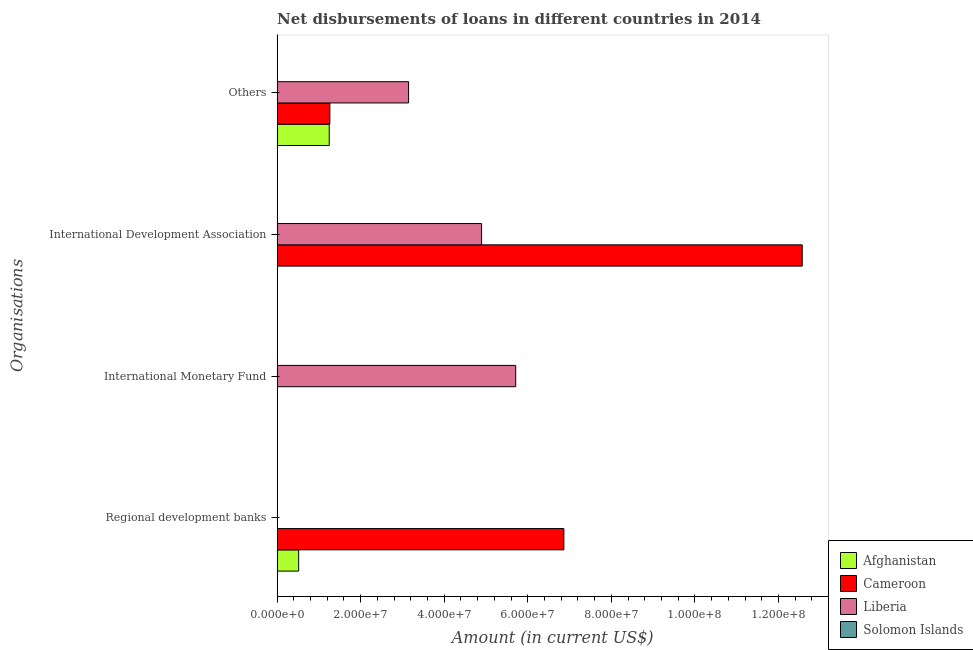How many different coloured bars are there?
Your answer should be compact. 3. Are the number of bars on each tick of the Y-axis equal?
Offer a very short reply. No. How many bars are there on the 1st tick from the top?
Make the answer very short. 3. What is the label of the 3rd group of bars from the top?
Your answer should be compact. International Monetary Fund. What is the amount of loan disimbursed by international development association in Cameroon?
Your answer should be compact. 1.26e+08. Across all countries, what is the maximum amount of loan disimbursed by international development association?
Your answer should be compact. 1.26e+08. In which country was the amount of loan disimbursed by international development association maximum?
Provide a short and direct response. Cameroon. What is the total amount of loan disimbursed by other organisations in the graph?
Offer a very short reply. 5.66e+07. What is the difference between the amount of loan disimbursed by regional development banks in Cameroon and that in Afghanistan?
Keep it short and to the point. 6.35e+07. What is the difference between the amount of loan disimbursed by international monetary fund in Cameroon and the amount of loan disimbursed by regional development banks in Afghanistan?
Provide a succinct answer. -5.16e+06. What is the average amount of loan disimbursed by other organisations per country?
Make the answer very short. 1.41e+07. What is the difference between the amount of loan disimbursed by regional development banks and amount of loan disimbursed by other organisations in Afghanistan?
Ensure brevity in your answer.  -7.32e+06. In how many countries, is the amount of loan disimbursed by international development association greater than 72000000 US$?
Offer a terse response. 1. What is the difference between the highest and the second highest amount of loan disimbursed by other organisations?
Your answer should be compact. 1.88e+07. What is the difference between the highest and the lowest amount of loan disimbursed by international development association?
Keep it short and to the point. 1.26e+08. In how many countries, is the amount of loan disimbursed by international monetary fund greater than the average amount of loan disimbursed by international monetary fund taken over all countries?
Offer a very short reply. 1. Is it the case that in every country, the sum of the amount of loan disimbursed by regional development banks and amount of loan disimbursed by international monetary fund is greater than the amount of loan disimbursed by international development association?
Offer a terse response. No. Are all the bars in the graph horizontal?
Your answer should be compact. Yes. How many countries are there in the graph?
Your response must be concise. 4. Does the graph contain any zero values?
Ensure brevity in your answer.  Yes. Where does the legend appear in the graph?
Keep it short and to the point. Bottom right. What is the title of the graph?
Provide a short and direct response. Net disbursements of loans in different countries in 2014. Does "OECD members" appear as one of the legend labels in the graph?
Make the answer very short. No. What is the label or title of the X-axis?
Provide a short and direct response. Amount (in current US$). What is the label or title of the Y-axis?
Provide a succinct answer. Organisations. What is the Amount (in current US$) of Afghanistan in Regional development banks?
Offer a terse response. 5.16e+06. What is the Amount (in current US$) of Cameroon in Regional development banks?
Your answer should be compact. 6.86e+07. What is the Amount (in current US$) in Afghanistan in International Monetary Fund?
Give a very brief answer. 0. What is the Amount (in current US$) in Cameroon in International Monetary Fund?
Offer a terse response. 0. What is the Amount (in current US$) of Liberia in International Monetary Fund?
Give a very brief answer. 5.71e+07. What is the Amount (in current US$) in Afghanistan in International Development Association?
Offer a very short reply. 0. What is the Amount (in current US$) of Cameroon in International Development Association?
Make the answer very short. 1.26e+08. What is the Amount (in current US$) of Liberia in International Development Association?
Provide a short and direct response. 4.89e+07. What is the Amount (in current US$) in Afghanistan in Others?
Your answer should be compact. 1.25e+07. What is the Amount (in current US$) in Cameroon in Others?
Offer a terse response. 1.26e+07. What is the Amount (in current US$) in Liberia in Others?
Ensure brevity in your answer.  3.15e+07. Across all Organisations, what is the maximum Amount (in current US$) of Afghanistan?
Your answer should be compact. 1.25e+07. Across all Organisations, what is the maximum Amount (in current US$) in Cameroon?
Offer a very short reply. 1.26e+08. Across all Organisations, what is the maximum Amount (in current US$) of Liberia?
Make the answer very short. 5.71e+07. Across all Organisations, what is the minimum Amount (in current US$) in Afghanistan?
Your answer should be very brief. 0. What is the total Amount (in current US$) in Afghanistan in the graph?
Your answer should be compact. 1.76e+07. What is the total Amount (in current US$) in Cameroon in the graph?
Offer a very short reply. 2.07e+08. What is the total Amount (in current US$) in Liberia in the graph?
Keep it short and to the point. 1.38e+08. What is the difference between the Amount (in current US$) in Cameroon in Regional development banks and that in International Development Association?
Ensure brevity in your answer.  -5.70e+07. What is the difference between the Amount (in current US$) of Afghanistan in Regional development banks and that in Others?
Provide a succinct answer. -7.32e+06. What is the difference between the Amount (in current US$) in Cameroon in Regional development banks and that in Others?
Keep it short and to the point. 5.60e+07. What is the difference between the Amount (in current US$) of Liberia in International Monetary Fund and that in International Development Association?
Make the answer very short. 8.16e+06. What is the difference between the Amount (in current US$) of Liberia in International Monetary Fund and that in Others?
Ensure brevity in your answer.  2.56e+07. What is the difference between the Amount (in current US$) of Cameroon in International Development Association and that in Others?
Your answer should be compact. 1.13e+08. What is the difference between the Amount (in current US$) in Liberia in International Development Association and that in Others?
Give a very brief answer. 1.75e+07. What is the difference between the Amount (in current US$) in Afghanistan in Regional development banks and the Amount (in current US$) in Liberia in International Monetary Fund?
Provide a succinct answer. -5.19e+07. What is the difference between the Amount (in current US$) in Cameroon in Regional development banks and the Amount (in current US$) in Liberia in International Monetary Fund?
Give a very brief answer. 1.15e+07. What is the difference between the Amount (in current US$) of Afghanistan in Regional development banks and the Amount (in current US$) of Cameroon in International Development Association?
Ensure brevity in your answer.  -1.21e+08. What is the difference between the Amount (in current US$) of Afghanistan in Regional development banks and the Amount (in current US$) of Liberia in International Development Association?
Provide a succinct answer. -4.38e+07. What is the difference between the Amount (in current US$) of Cameroon in Regional development banks and the Amount (in current US$) of Liberia in International Development Association?
Keep it short and to the point. 1.97e+07. What is the difference between the Amount (in current US$) of Afghanistan in Regional development banks and the Amount (in current US$) of Cameroon in Others?
Ensure brevity in your answer.  -7.46e+06. What is the difference between the Amount (in current US$) in Afghanistan in Regional development banks and the Amount (in current US$) in Liberia in Others?
Keep it short and to the point. -2.63e+07. What is the difference between the Amount (in current US$) in Cameroon in Regional development banks and the Amount (in current US$) in Liberia in Others?
Offer a very short reply. 3.72e+07. What is the difference between the Amount (in current US$) of Cameroon in International Development Association and the Amount (in current US$) of Liberia in Others?
Offer a terse response. 9.42e+07. What is the average Amount (in current US$) in Afghanistan per Organisations?
Your response must be concise. 4.41e+06. What is the average Amount (in current US$) of Cameroon per Organisations?
Make the answer very short. 5.17e+07. What is the average Amount (in current US$) in Liberia per Organisations?
Give a very brief answer. 3.44e+07. What is the average Amount (in current US$) in Solomon Islands per Organisations?
Provide a short and direct response. 0. What is the difference between the Amount (in current US$) of Afghanistan and Amount (in current US$) of Cameroon in Regional development banks?
Provide a short and direct response. -6.35e+07. What is the difference between the Amount (in current US$) of Cameroon and Amount (in current US$) of Liberia in International Development Association?
Provide a succinct answer. 7.67e+07. What is the difference between the Amount (in current US$) in Afghanistan and Amount (in current US$) in Cameroon in Others?
Offer a very short reply. -1.45e+05. What is the difference between the Amount (in current US$) in Afghanistan and Amount (in current US$) in Liberia in Others?
Offer a very short reply. -1.90e+07. What is the difference between the Amount (in current US$) of Cameroon and Amount (in current US$) of Liberia in Others?
Provide a short and direct response. -1.88e+07. What is the ratio of the Amount (in current US$) of Cameroon in Regional development banks to that in International Development Association?
Provide a short and direct response. 0.55. What is the ratio of the Amount (in current US$) in Afghanistan in Regional development banks to that in Others?
Offer a terse response. 0.41. What is the ratio of the Amount (in current US$) of Cameroon in Regional development banks to that in Others?
Your response must be concise. 5.44. What is the ratio of the Amount (in current US$) of Liberia in International Monetary Fund to that in International Development Association?
Offer a very short reply. 1.17. What is the ratio of the Amount (in current US$) in Liberia in International Monetary Fund to that in Others?
Your response must be concise. 1.81. What is the ratio of the Amount (in current US$) in Cameroon in International Development Association to that in Others?
Your response must be concise. 9.96. What is the ratio of the Amount (in current US$) of Liberia in International Development Association to that in Others?
Provide a succinct answer. 1.56. What is the difference between the highest and the second highest Amount (in current US$) in Cameroon?
Keep it short and to the point. 5.70e+07. What is the difference between the highest and the second highest Amount (in current US$) in Liberia?
Provide a short and direct response. 8.16e+06. What is the difference between the highest and the lowest Amount (in current US$) of Afghanistan?
Give a very brief answer. 1.25e+07. What is the difference between the highest and the lowest Amount (in current US$) in Cameroon?
Provide a short and direct response. 1.26e+08. What is the difference between the highest and the lowest Amount (in current US$) in Liberia?
Provide a short and direct response. 5.71e+07. 